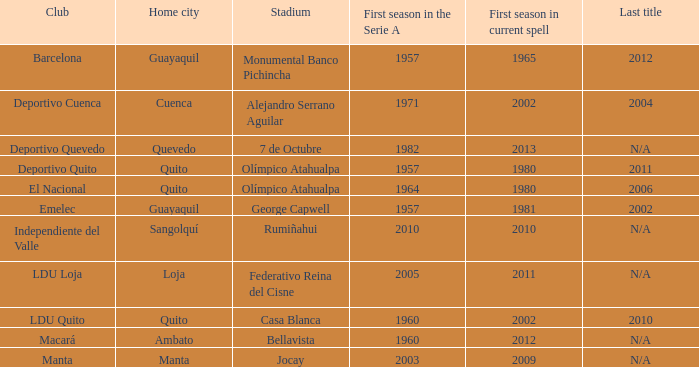Name the club for quevedo Deportivo Quevedo. 